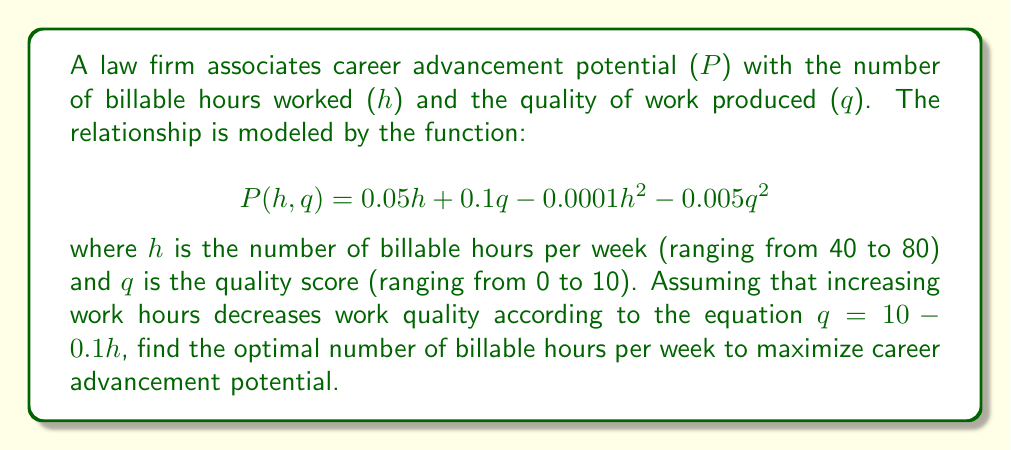Provide a solution to this math problem. To solve this optimization problem, we need to follow these steps:

1) First, we substitute the quality equation into the career advancement potential function:

   $$P(h) = 0.05h + 0.1(10 - 0.1h) - 0.0001h^2 - 0.005(10 - 0.1h)^2$$

2) Expand the equation:

   $$P(h) = 0.05h + 1 - 0.01h - 0.0001h^2 - 0.005(100 - 2h + 0.01h^2)$$
   $$P(h) = 0.05h + 1 - 0.01h - 0.0001h^2 - 0.5 + 0.01h - 0.00005h^2$$

3) Simplify:

   $$P(h) = 0.05h - 0.00015h^2 + 0.5$$

4) To find the maximum, we differentiate P(h) with respect to h and set it to zero:

   $$\frac{dP}{dh} = 0.05 - 0.0003h = 0$$

5) Solve for h:

   $$0.0003h = 0.05$$
   $$h = \frac{0.05}{0.0003} \approx 166.67$$

6) Check the second derivative to confirm it's a maximum:

   $$\frac{d^2P}{dh^2} = -0.0003 < 0$$

   This confirms it's a maximum.

7) However, we need to consider the constraints. The question states that h ranges from 40 to 80 hours. Since our calculated value is outside this range, the maximum within our constraints will be at one of the endpoints.

8) Evaluate P(h) at h = 40 and h = 80:

   P(40) = 0.05(40) - 0.00015(40^2) + 0.5 = 2.26
   P(80) = 0.05(80) - 0.00015(80^2) + 0.5 = 2.02

Therefore, the maximum occurs at h = 40 hours.
Answer: The optimal number of billable hours per week to maximize career advancement potential is 40 hours. 